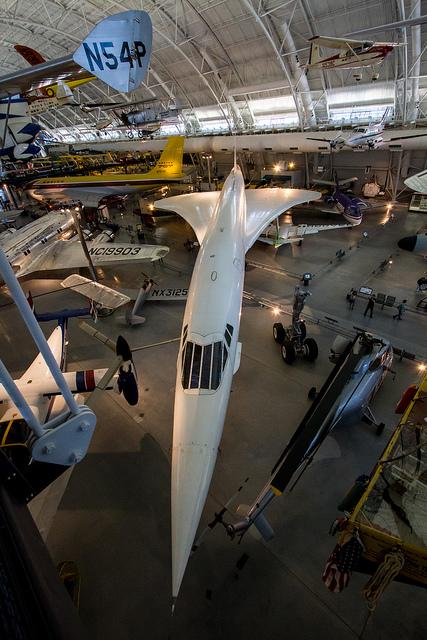Where are the planes stored?
Quick response, please. Hanger. What color is the first plane?
Be succinct. White. What angle was this picture taken from?
Be succinct. Above. Is there a yellow plane?
Short answer required. Yes. 